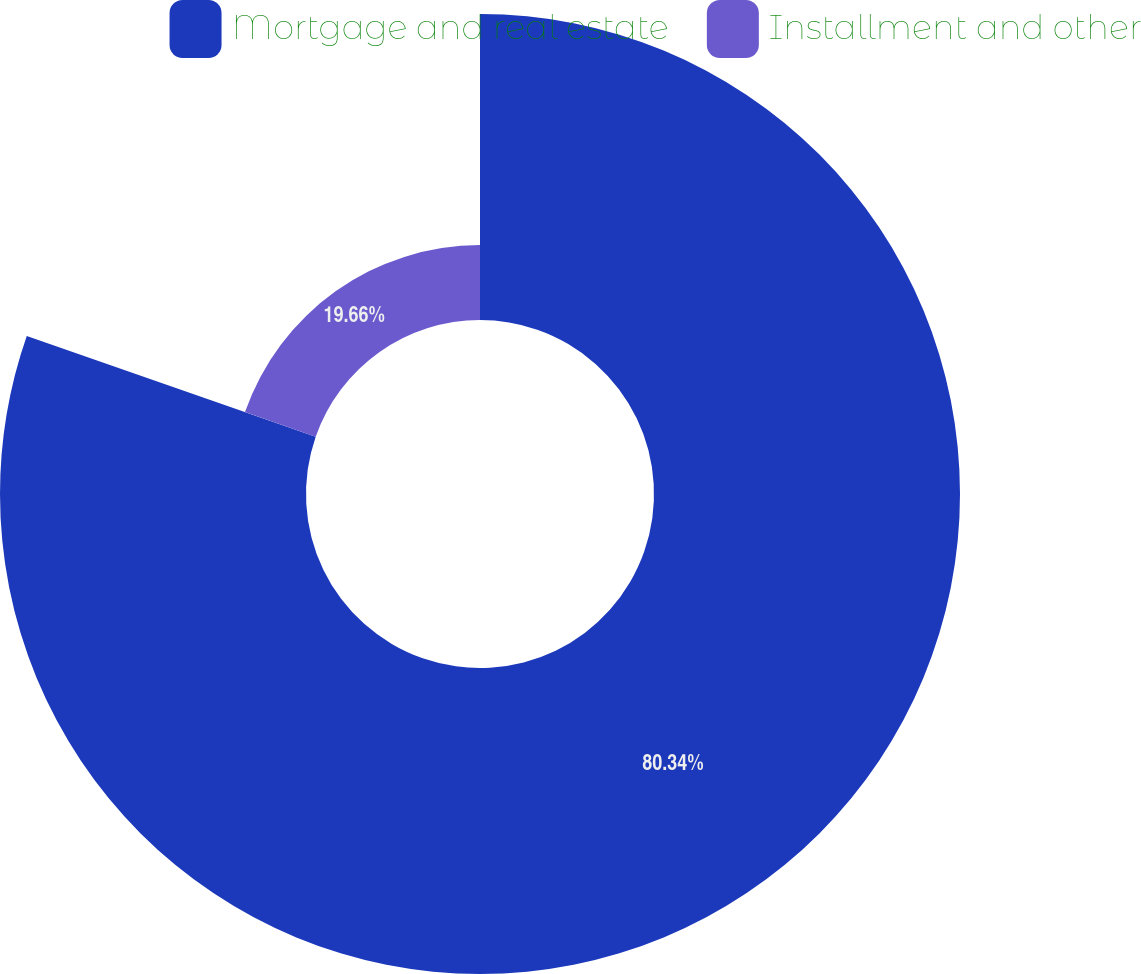Convert chart to OTSL. <chart><loc_0><loc_0><loc_500><loc_500><pie_chart><fcel>Mortgage and real estate<fcel>Installment and other<nl><fcel>80.34%<fcel>19.66%<nl></chart> 